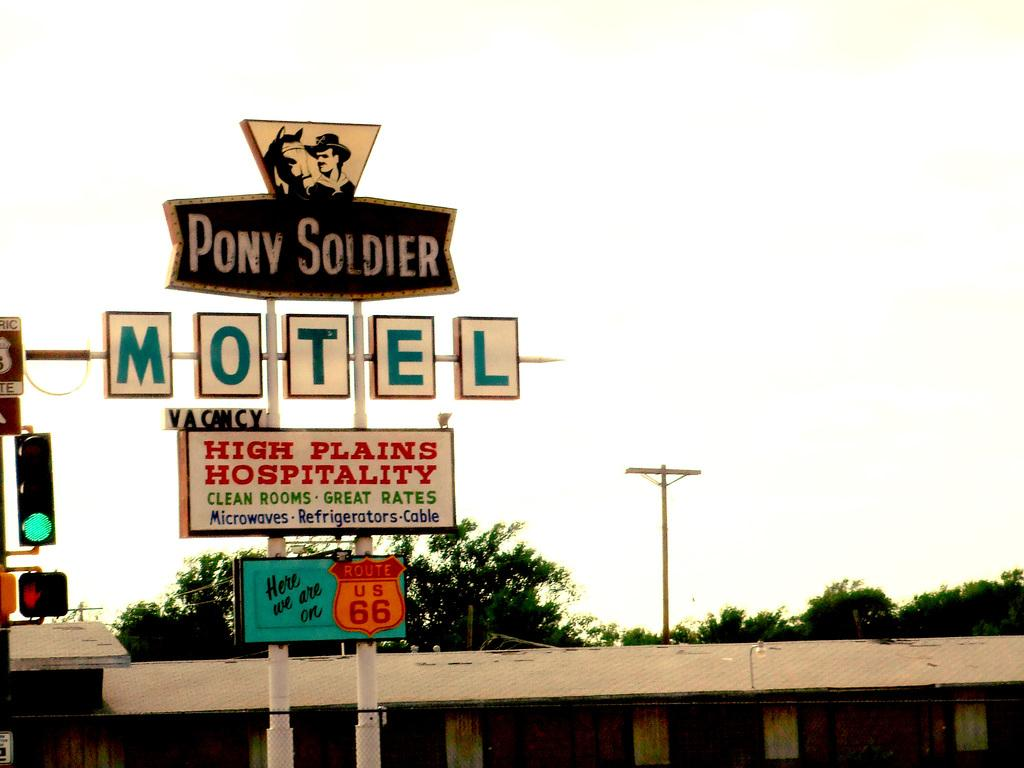<image>
Relay a brief, clear account of the picture shown. A motel sign that says Pony Soldier on it. 